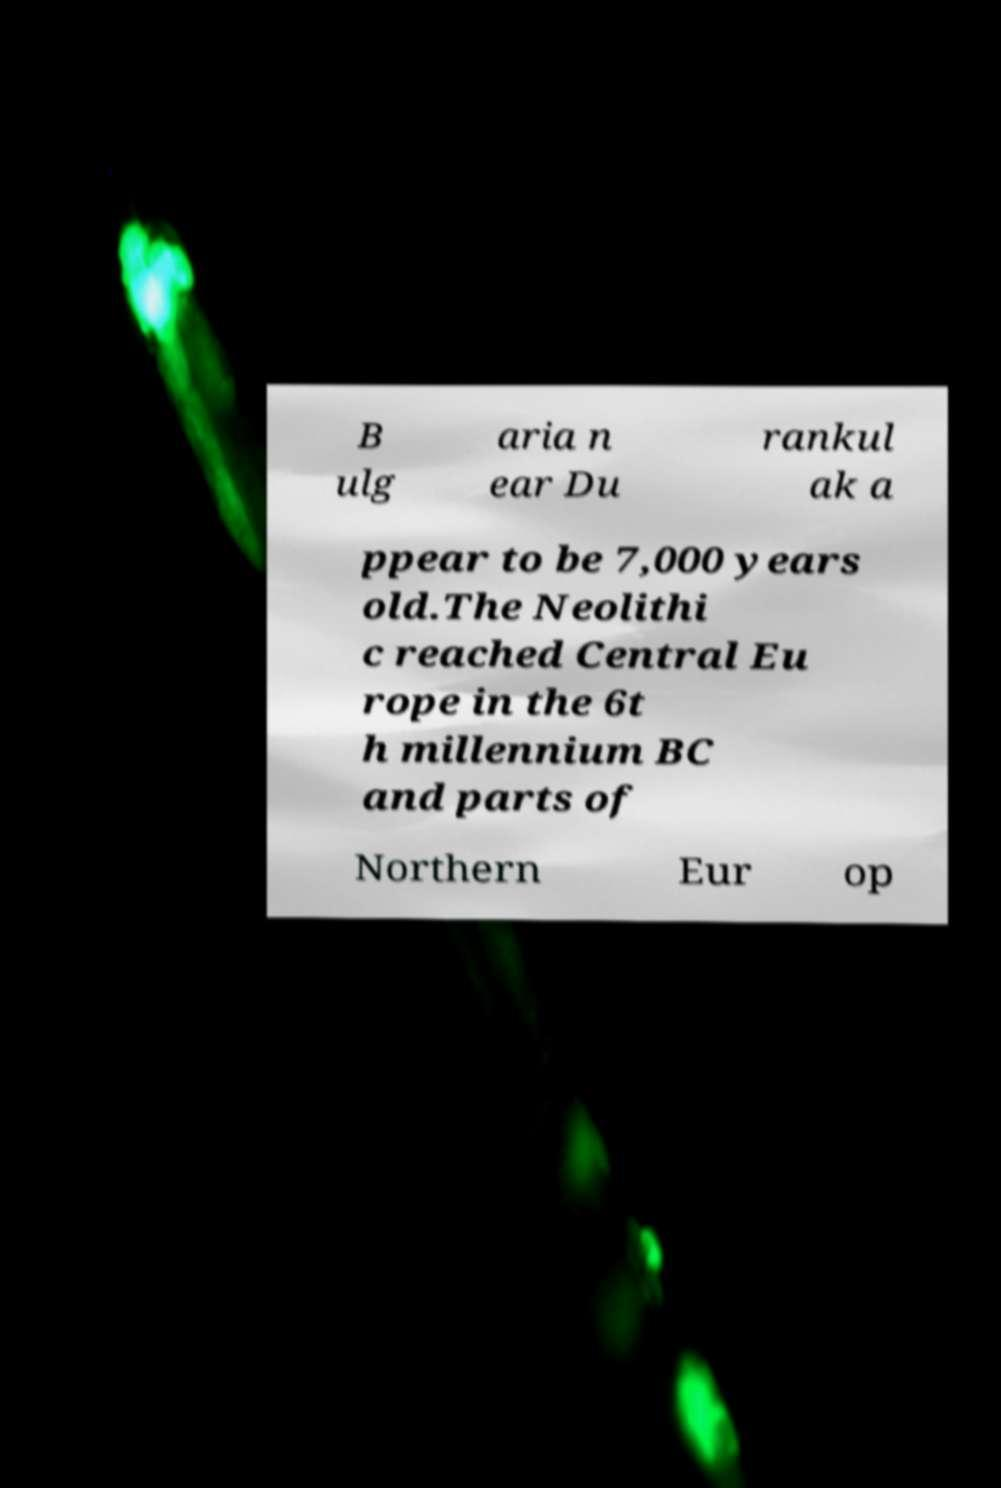What messages or text are displayed in this image? I need them in a readable, typed format. B ulg aria n ear Du rankul ak a ppear to be 7,000 years old.The Neolithi c reached Central Eu rope in the 6t h millennium BC and parts of Northern Eur op 